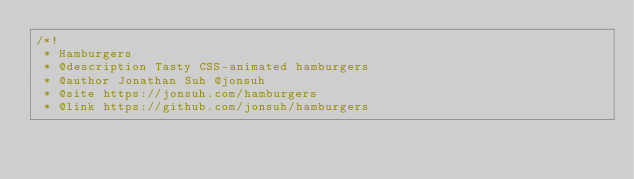Convert code to text. <code><loc_0><loc_0><loc_500><loc_500><_CSS_>/*!
 * Hamburgers
 * @description Tasty CSS-animated hamburgers
 * @author Jonathan Suh @jonsuh
 * @site https://jonsuh.com/hamburgers
 * @link https://github.com/jonsuh/hamburgers</code> 